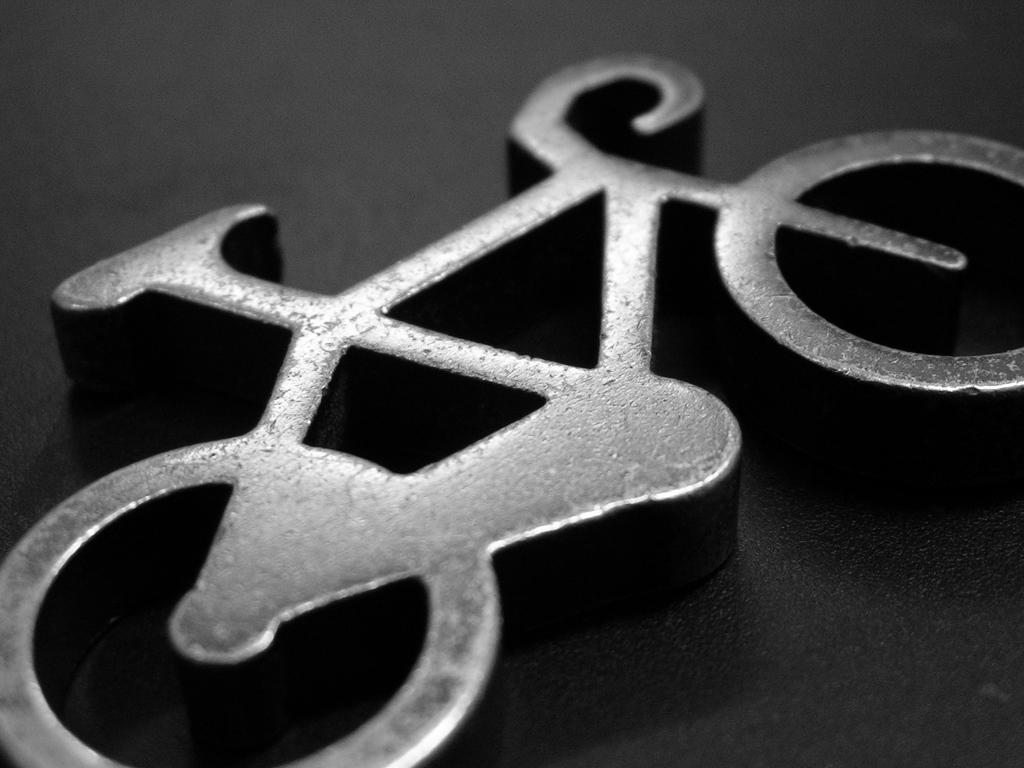What type of vehicle is present in the image? There is a metallic cycle in the image. Can you describe the material of the cycle? The cycle is made of metal. What type of noise does the metallic cycle make in the image? The image does not provide any information about the cycle making noise, so we cannot determine the type of noise it makes. 